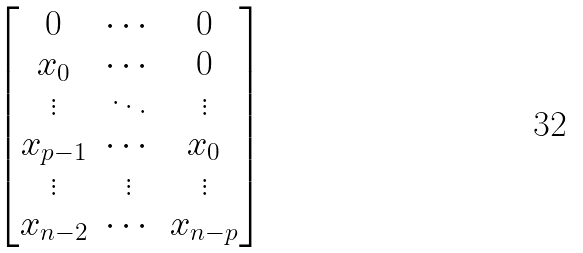<formula> <loc_0><loc_0><loc_500><loc_500>\begin{bmatrix} 0 & \cdots & 0 \\ x _ { 0 } & \cdots & 0 \\ \vdots & \ddots & \vdots \\ x _ { p - 1 } & \cdots & x _ { 0 } \\ \vdots & \vdots & \vdots \\ x _ { n - 2 } & \cdots & x _ { n - p } \end{bmatrix}</formula> 